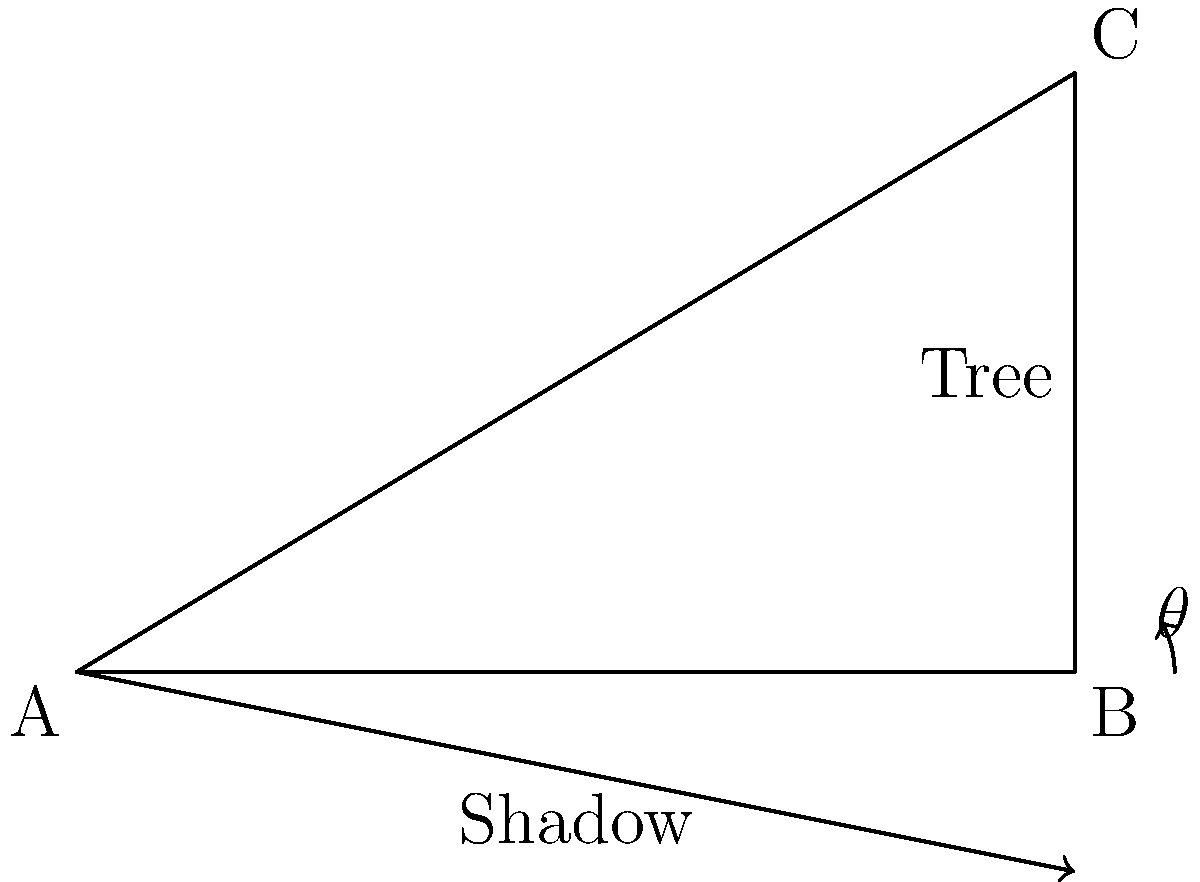While studying the behavior of arboreal insects in a Thai forest, you need to measure the height of a tall tree. You notice that the angle of elevation from the end of the tree's shadow to its top is 31°. If the length of the shadow is 15 meters, what is the height of the tree? Round your answer to the nearest tenth of a meter. To solve this problem, we'll use trigonometry. Let's break it down step-by-step:

1) In the right triangle formed by the tree, its shadow, and the line of sight, we know:
   - The angle of elevation (θ) = 31°
   - The length of the shadow (adjacent side) = 15 meters
   - We need to find the height of the tree (opposite side)

2) The trigonometric ratio that relates the opposite side to the adjacent side is the tangent:

   $$\tan \theta = \frac{\text{opposite}}{\text{adjacent}}$$

3) Substituting our known values:

   $$\tan 31° = \frac{\text{height}}{15}$$

4) To solve for the height, we multiply both sides by 15:

   $$15 \cdot \tan 31° = \text{height}$$

5) Now, let's calculate:
   
   $$\text{height} = 15 \cdot \tan 31° \approx 15 \cdot 0.6009 \approx 9.0135$$

6) Rounding to the nearest tenth:

   $$\text{height} \approx 9.0 \text{ meters}$$
Answer: 9.0 meters 